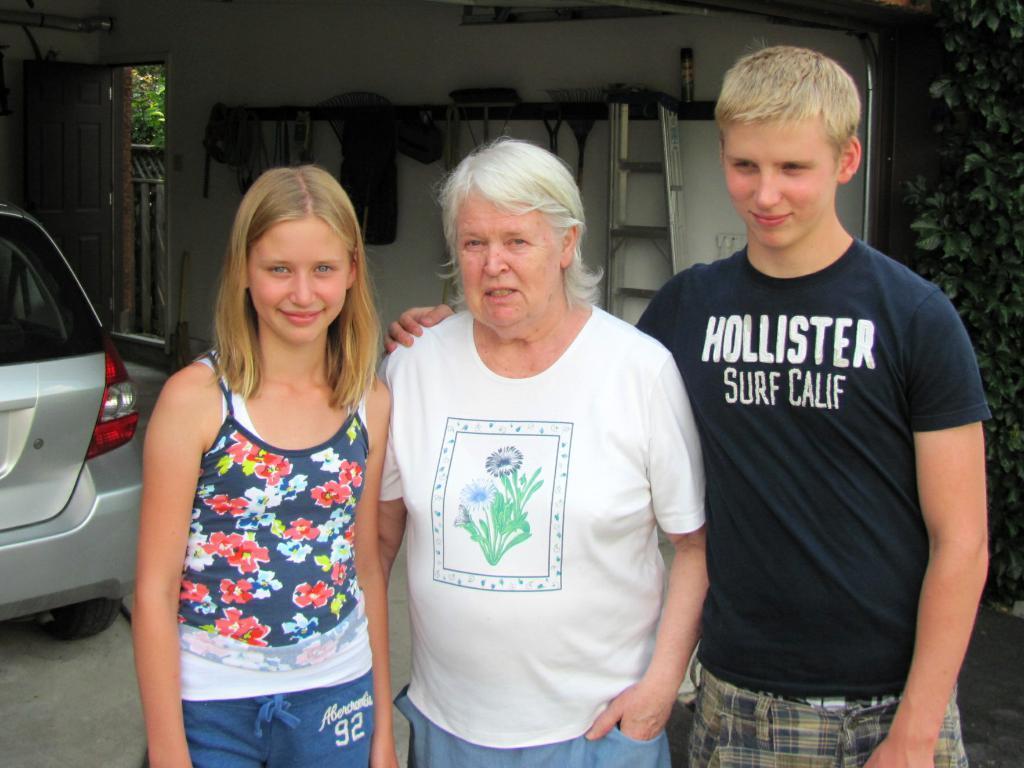Can you describe this image briefly? There are three persons standing. On the left side there is a car. In the back there is a wall, door, ladder and a stand on the wall. On that there are many items. On the right side we can see leaves. 